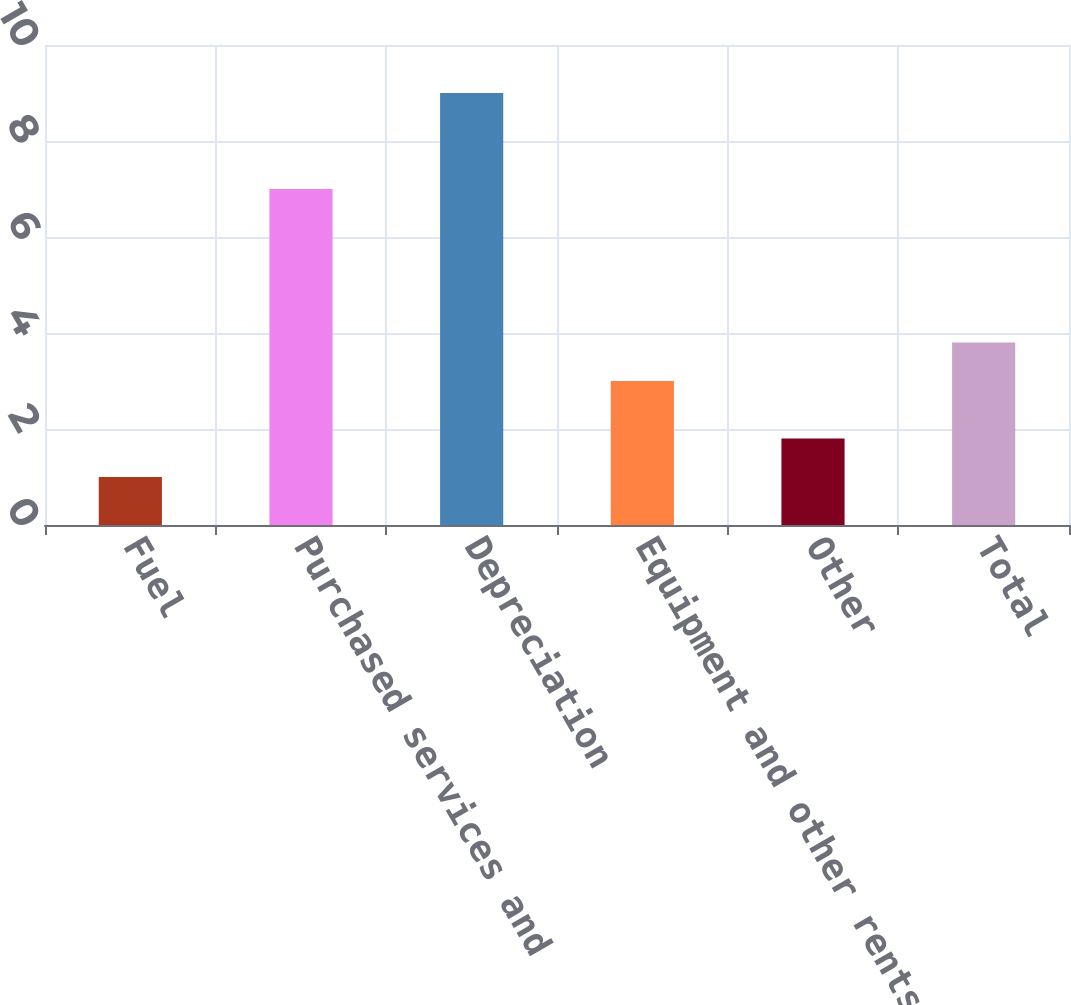Convert chart. <chart><loc_0><loc_0><loc_500><loc_500><bar_chart><fcel>Fuel<fcel>Purchased services and<fcel>Depreciation<fcel>Equipment and other rents<fcel>Other<fcel>Total<nl><fcel>1<fcel>7<fcel>9<fcel>3<fcel>1.8<fcel>3.8<nl></chart> 